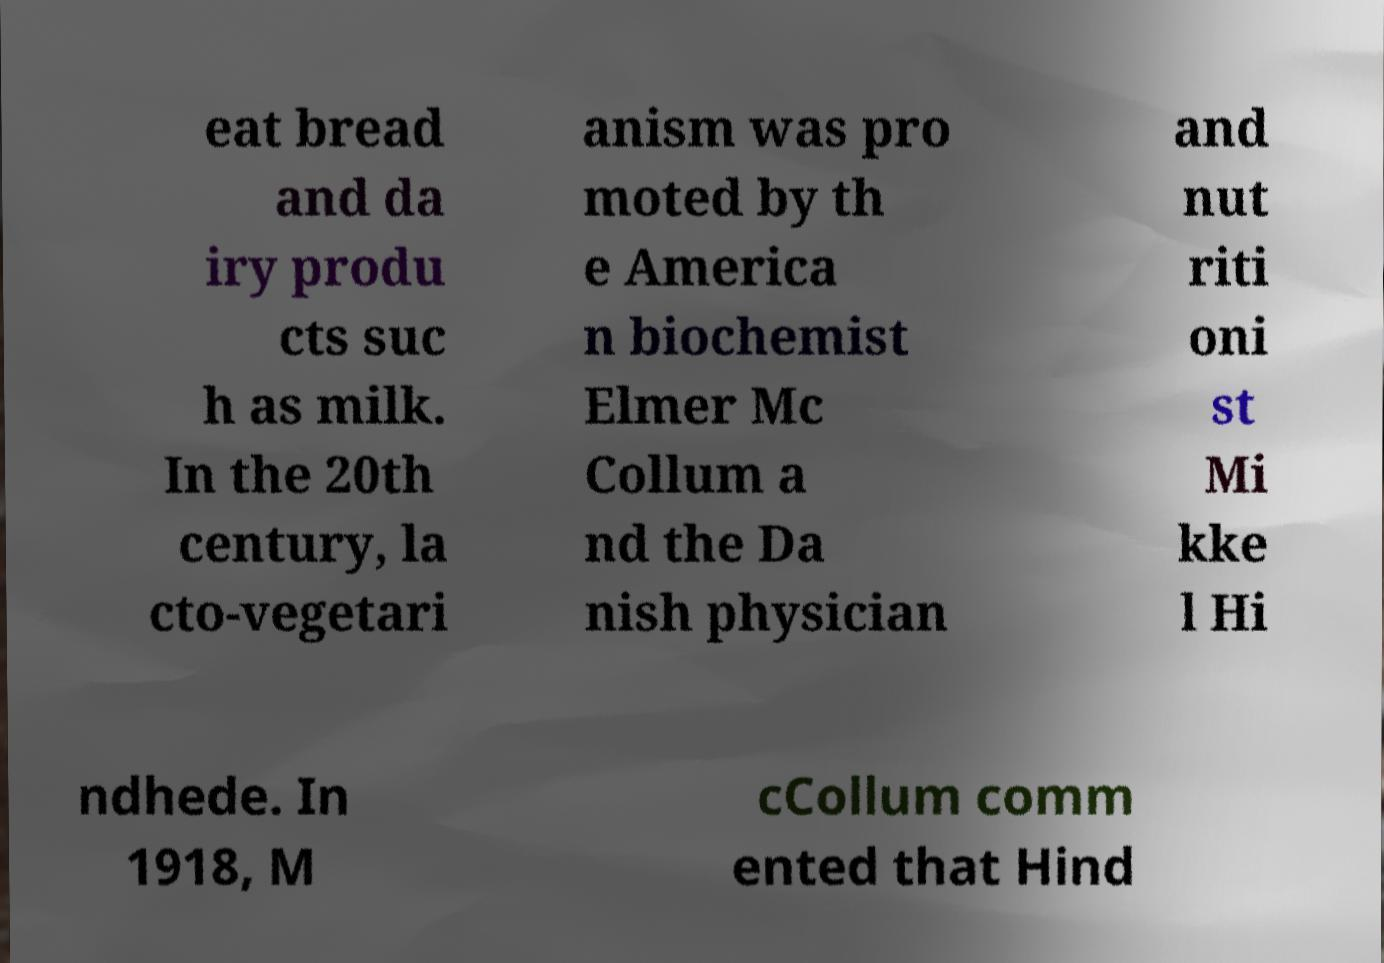There's text embedded in this image that I need extracted. Can you transcribe it verbatim? eat bread and da iry produ cts suc h as milk. In the 20th century, la cto-vegetari anism was pro moted by th e America n biochemist Elmer Mc Collum a nd the Da nish physician and nut riti oni st Mi kke l Hi ndhede. In 1918, M cCollum comm ented that Hind 